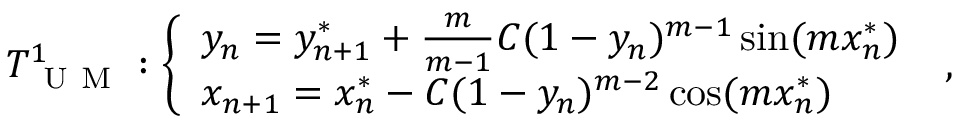Convert formula to latex. <formula><loc_0><loc_0><loc_500><loc_500>T _ { U M } ^ { 1 } \colon \left \{ \begin{array} { l l } { y _ { n } = y _ { n + 1 } ^ { * } + \frac { m } { m - 1 } C ( 1 - y _ { n } ) ^ { m - 1 } \sin ( m x _ { n } ^ { * } ) } \\ { x _ { n + 1 } = x _ { n } ^ { * } - C ( 1 - y _ { n } ) ^ { m - 2 } \cos ( m x _ { n } ^ { * } ) } \end{array} ,</formula> 